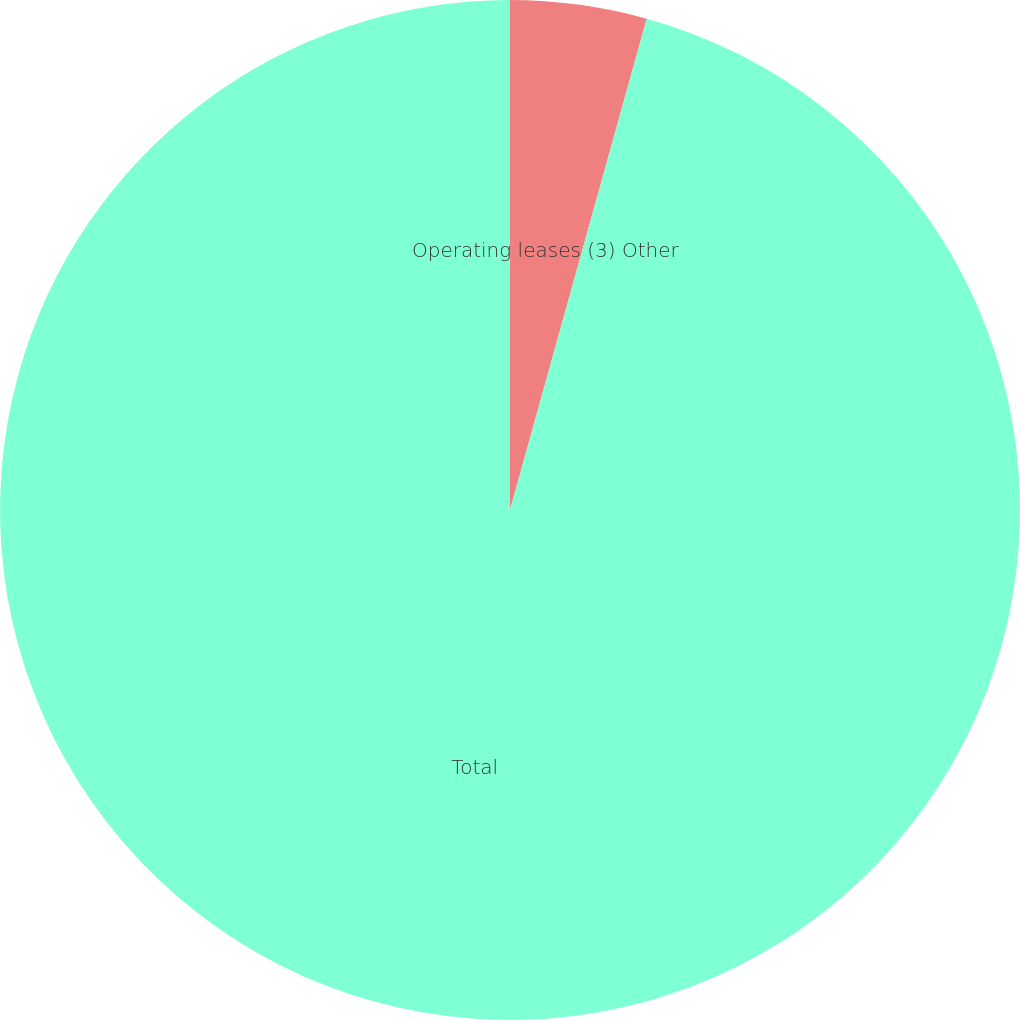Convert chart to OTSL. <chart><loc_0><loc_0><loc_500><loc_500><pie_chart><fcel>Operating leases (3) Other<fcel>Total<nl><fcel>4.32%<fcel>95.68%<nl></chart> 